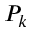Convert formula to latex. <formula><loc_0><loc_0><loc_500><loc_500>P _ { k }</formula> 